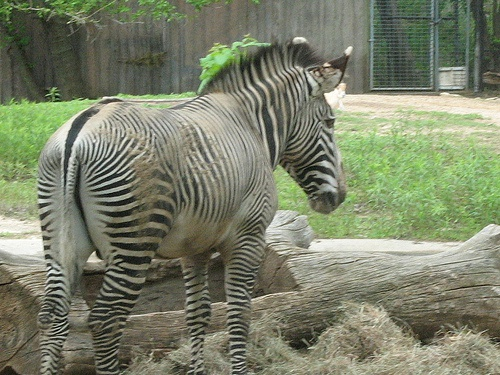Describe the objects in this image and their specific colors. I can see a zebra in darkgreen, gray, darkgray, and black tones in this image. 